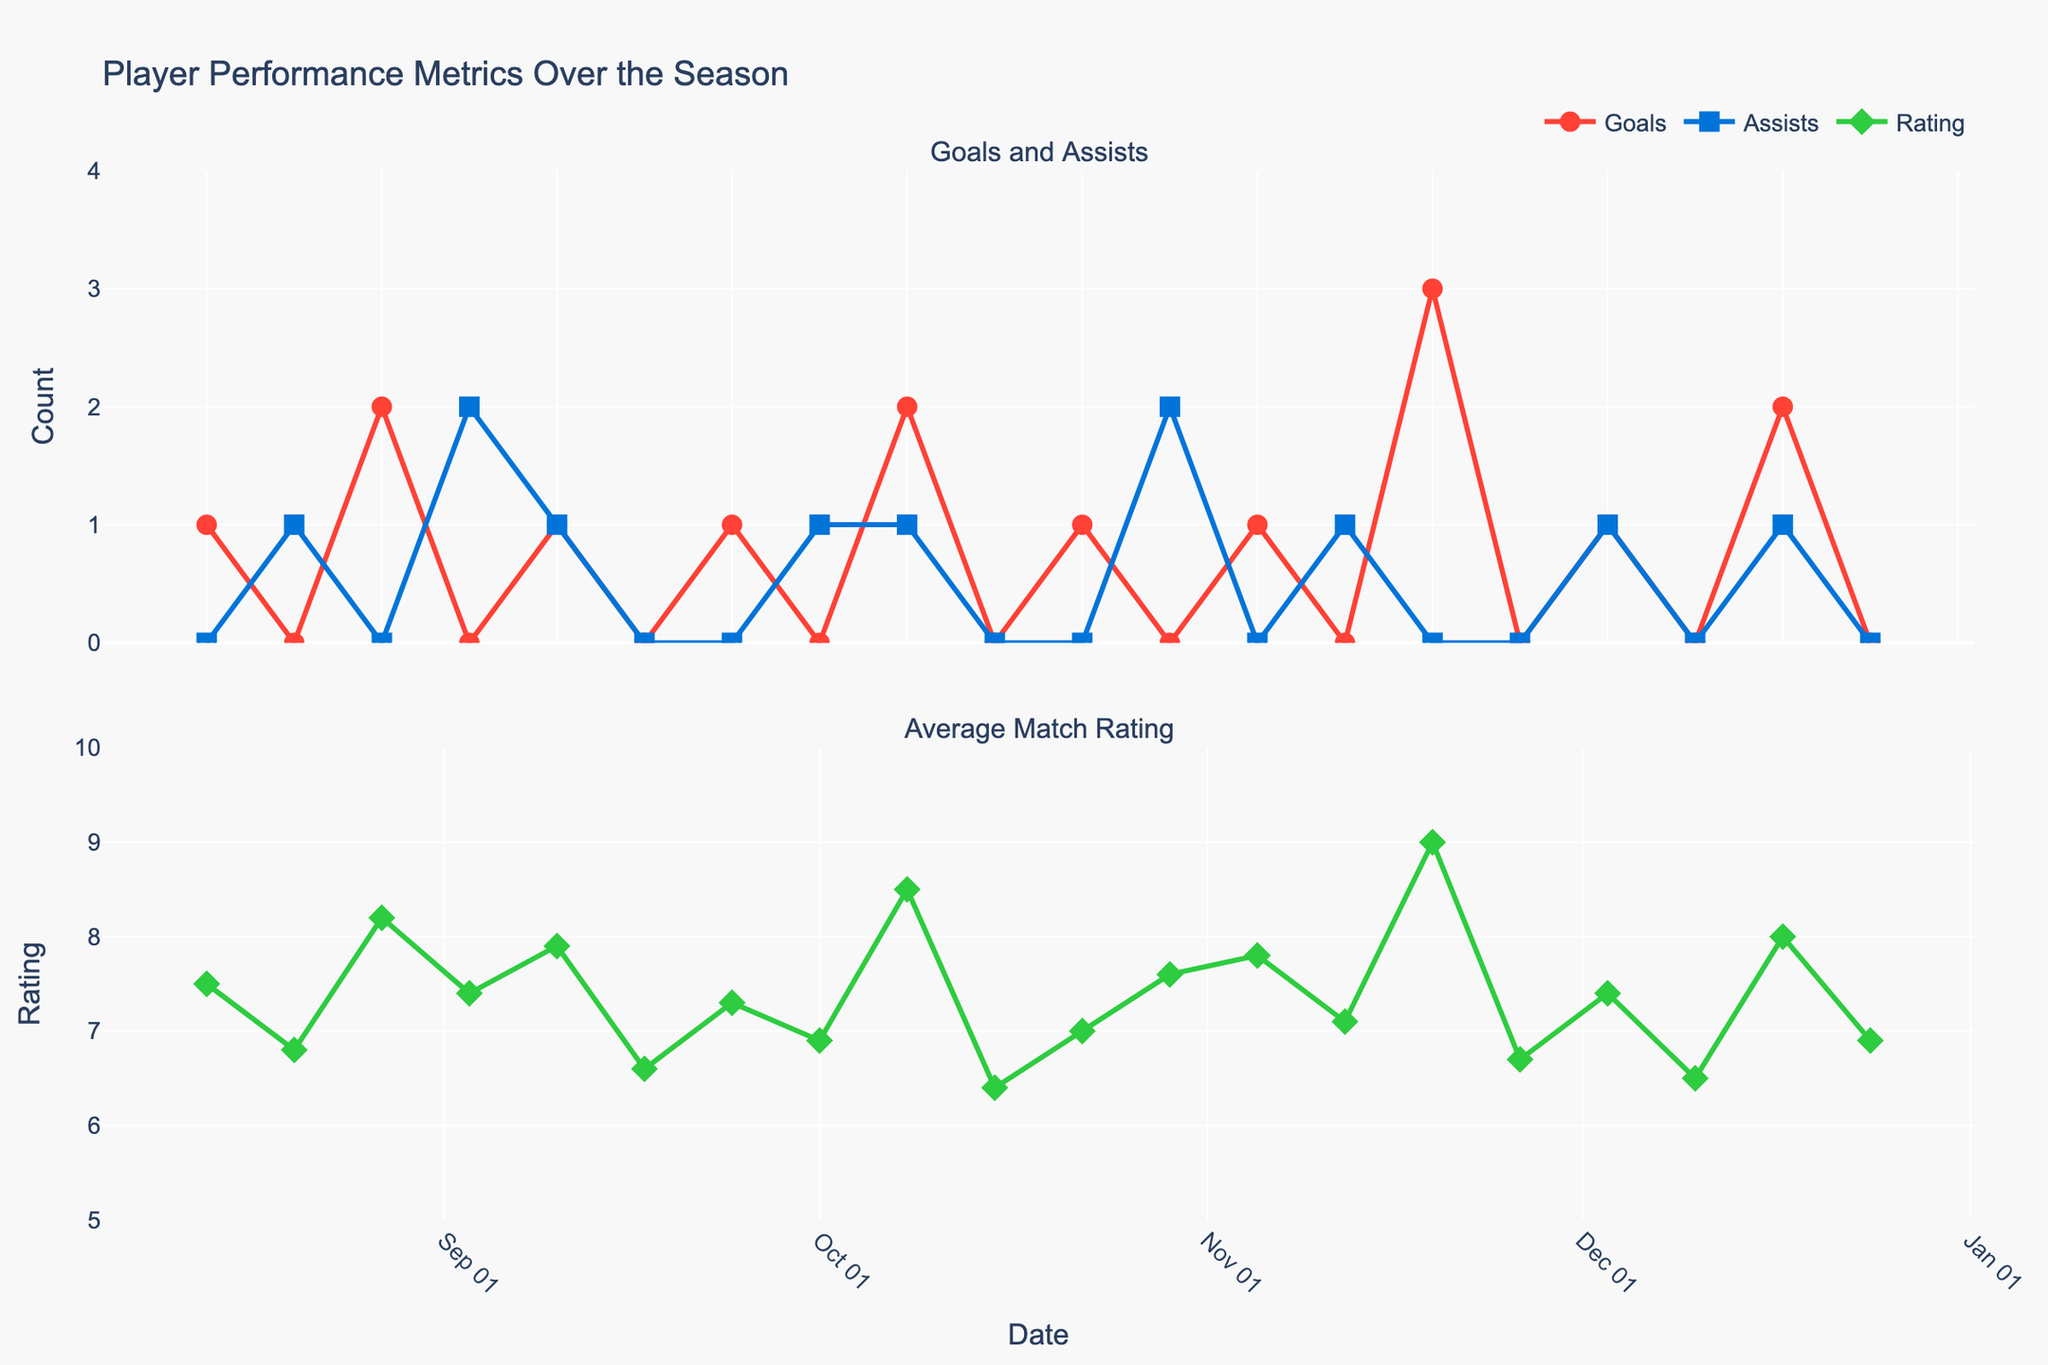What's the average match rating on 2023-08-27? Look at the second subplot for the Average Match Rating on 2023-08-27, it shows 8.2
Answer: 8.2 How many goals were scored on 2023-11-19? Refer to the first subplot for Goals Scored on 2023-11-19, it shows 3
Answer: 3 Which date shows the highest average match rating and what is that rating? Check the second subplot for the highest point, it's on 2023-11-19 with a rating of 9.0
Answer: 2023-11-19, 9.0 What is the total number of assists in November 2023? Sum the assists from the dates in November: 2023-11-05 (0), 2023-11-12 (1), 2023-11-19 (0), 2023-11-26 (0). The sum is 1
Answer: 1 Compare the goals scored on 2023-08-13 and 2023-11-19, which date has more goals and by how much? 2023-08-13 has 1 goal while 2023-11-19 has 3 goals, so 2023-11-19 has 2 more goals
Answer: 2023-11-19, 2 goals On which date did the player have both a goal and an assist in the same match? Look at the first subplot for dates that have both Goal (red circle marker) and Assist (blue square marker), it's 2023-09-10, 2023-10-08, 2023-12-03, and 2023-12-17
Answer: 2023-09-10, 2023-10-08, 2023-12-03, 2023-12-17 What is the total number of goals scored during the season displayed? Sum all the goals from each date: 1 + 0 + 2 + 0 + 1 + 0 + 1 + 0 + 2 + 0 + 1 + 0 + 1 + 0 + 3 + 0 + 1 + 0 + 2 + 0 = 15
Answer: 15 What is the average match rating in October 2023? Average the ratings from the dates in October: (6.9 + 7.0 + 7.6) / 3 = 7.17
Answer: 7.17 On which date was the player's average match rating the lowest and what was the rating? Check the second subplot for the lowest point, it's on 2023-10-15 with a rating of 6.4
Answer: 2023-10-15, 6.4 